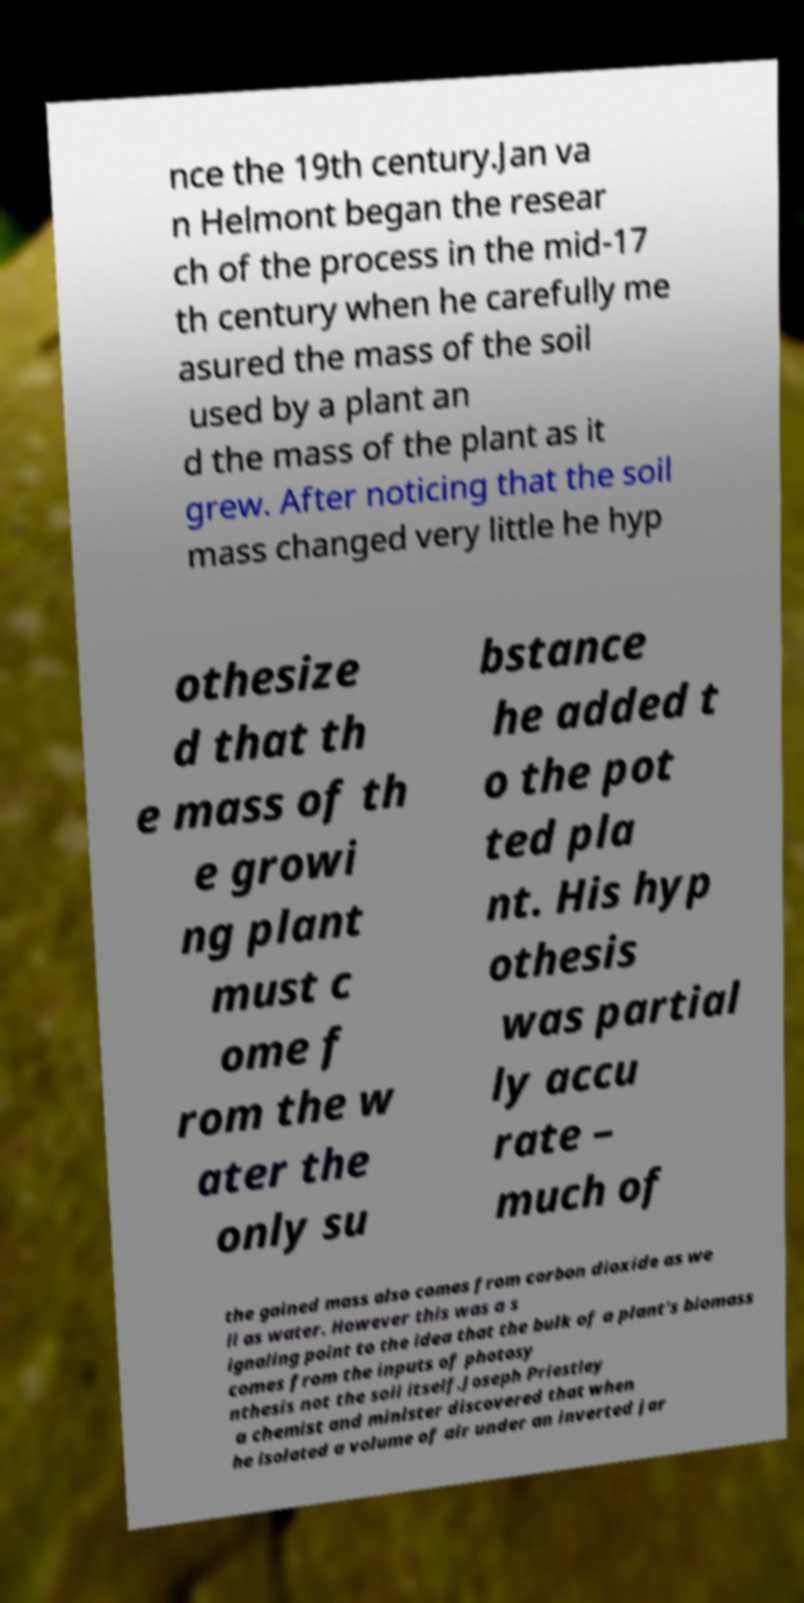I need the written content from this picture converted into text. Can you do that? nce the 19th century.Jan va n Helmont began the resear ch of the process in the mid-17 th century when he carefully me asured the mass of the soil used by a plant an d the mass of the plant as it grew. After noticing that the soil mass changed very little he hyp othesize d that th e mass of th e growi ng plant must c ome f rom the w ater the only su bstance he added t o the pot ted pla nt. His hyp othesis was partial ly accu rate – much of the gained mass also comes from carbon dioxide as we ll as water. However this was a s ignaling point to the idea that the bulk of a plant's biomass comes from the inputs of photosy nthesis not the soil itself.Joseph Priestley a chemist and minister discovered that when he isolated a volume of air under an inverted jar 